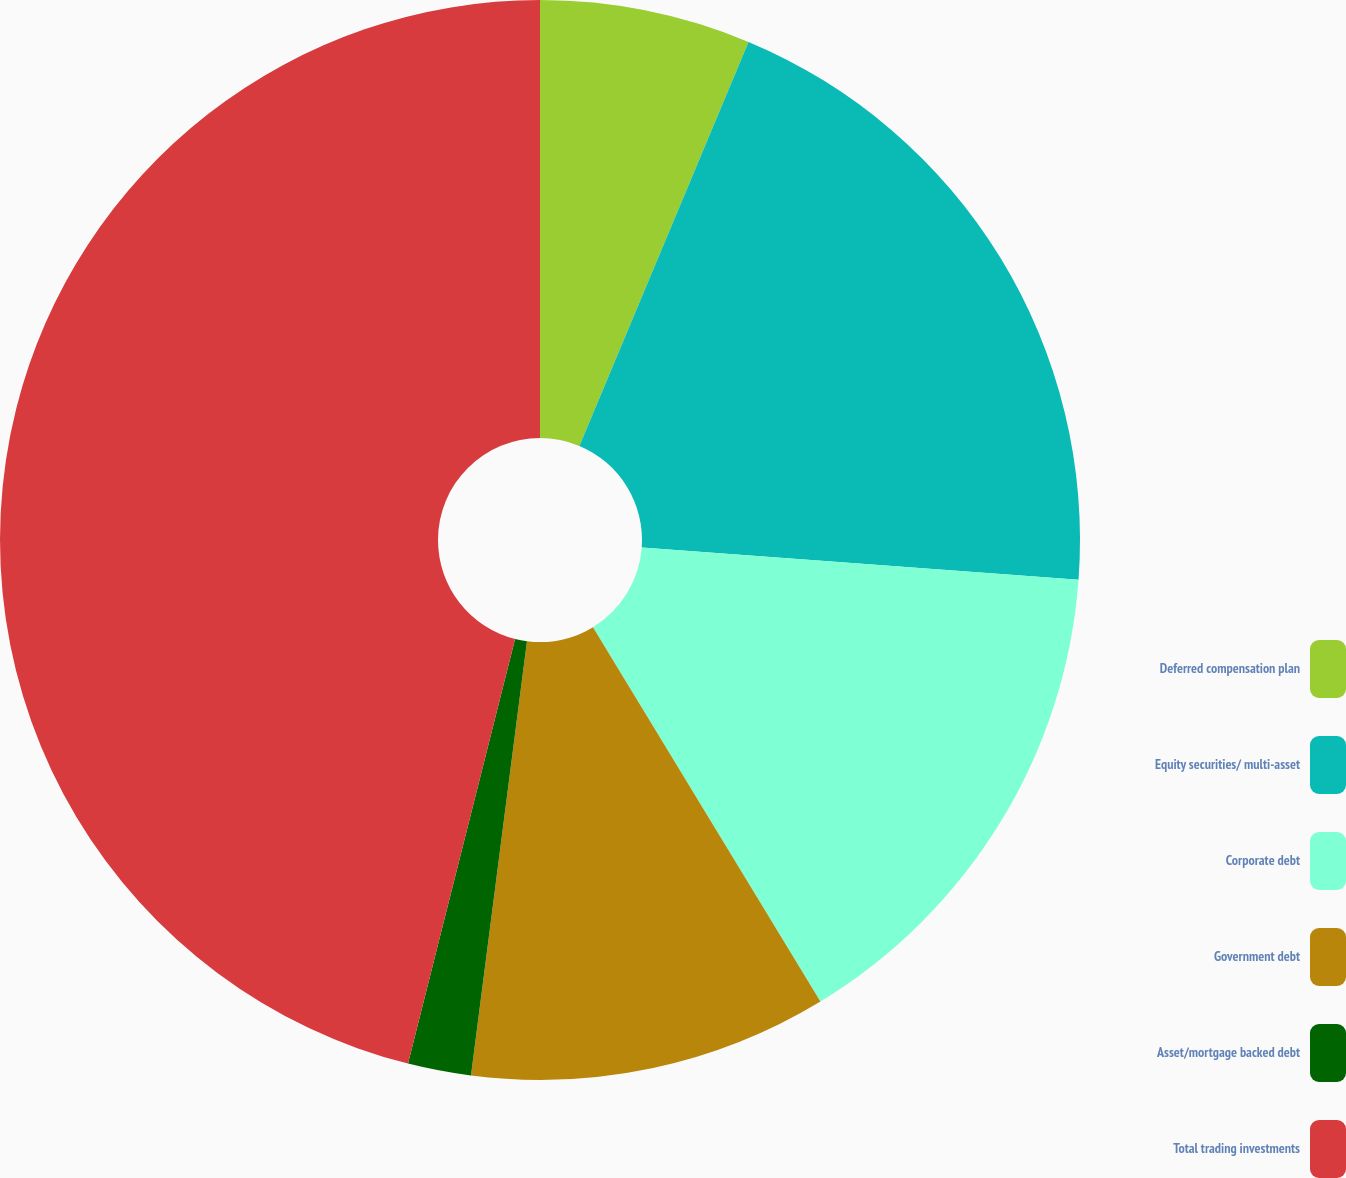<chart> <loc_0><loc_0><loc_500><loc_500><pie_chart><fcel>Deferred compensation plan<fcel>Equity securities/ multi-asset<fcel>Corporate debt<fcel>Government debt<fcel>Asset/mortgage backed debt<fcel>Total trading investments<nl><fcel>6.31%<fcel>19.86%<fcel>15.14%<fcel>10.73%<fcel>1.89%<fcel>46.07%<nl></chart> 